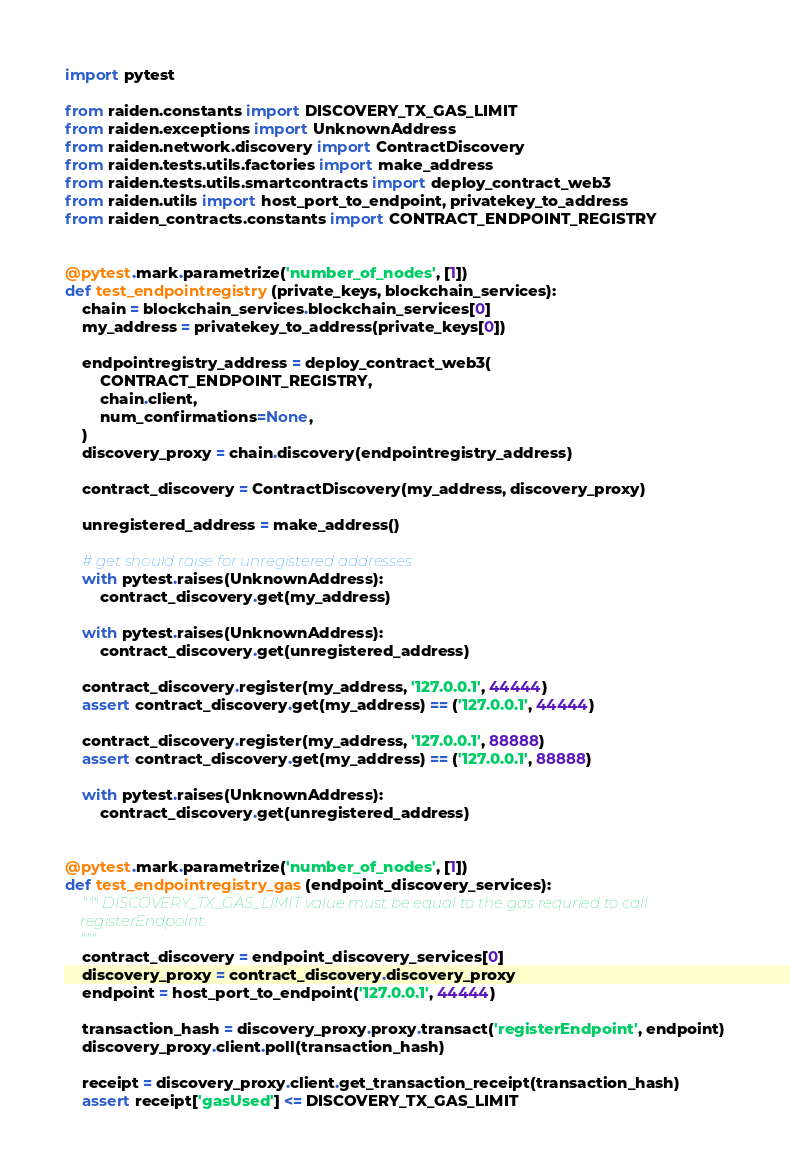<code> <loc_0><loc_0><loc_500><loc_500><_Python_>import pytest

from raiden.constants import DISCOVERY_TX_GAS_LIMIT
from raiden.exceptions import UnknownAddress
from raiden.network.discovery import ContractDiscovery
from raiden.tests.utils.factories import make_address
from raiden.tests.utils.smartcontracts import deploy_contract_web3
from raiden.utils import host_port_to_endpoint, privatekey_to_address
from raiden_contracts.constants import CONTRACT_ENDPOINT_REGISTRY


@pytest.mark.parametrize('number_of_nodes', [1])
def test_endpointregistry(private_keys, blockchain_services):
    chain = blockchain_services.blockchain_services[0]
    my_address = privatekey_to_address(private_keys[0])

    endpointregistry_address = deploy_contract_web3(
        CONTRACT_ENDPOINT_REGISTRY,
        chain.client,
        num_confirmations=None,
    )
    discovery_proxy = chain.discovery(endpointregistry_address)

    contract_discovery = ContractDiscovery(my_address, discovery_proxy)

    unregistered_address = make_address()

    # get should raise for unregistered addresses
    with pytest.raises(UnknownAddress):
        contract_discovery.get(my_address)

    with pytest.raises(UnknownAddress):
        contract_discovery.get(unregistered_address)

    contract_discovery.register(my_address, '127.0.0.1', 44444)
    assert contract_discovery.get(my_address) == ('127.0.0.1', 44444)

    contract_discovery.register(my_address, '127.0.0.1', 88888)
    assert contract_discovery.get(my_address) == ('127.0.0.1', 88888)

    with pytest.raises(UnknownAddress):
        contract_discovery.get(unregistered_address)


@pytest.mark.parametrize('number_of_nodes', [1])
def test_endpointregistry_gas(endpoint_discovery_services):
    """ DISCOVERY_TX_GAS_LIMIT value must be equal to the gas requried to call
    registerEndpoint.
    """
    contract_discovery = endpoint_discovery_services[0]
    discovery_proxy = contract_discovery.discovery_proxy
    endpoint = host_port_to_endpoint('127.0.0.1', 44444)

    transaction_hash = discovery_proxy.proxy.transact('registerEndpoint', endpoint)
    discovery_proxy.client.poll(transaction_hash)

    receipt = discovery_proxy.client.get_transaction_receipt(transaction_hash)
    assert receipt['gasUsed'] <= DISCOVERY_TX_GAS_LIMIT
</code> 